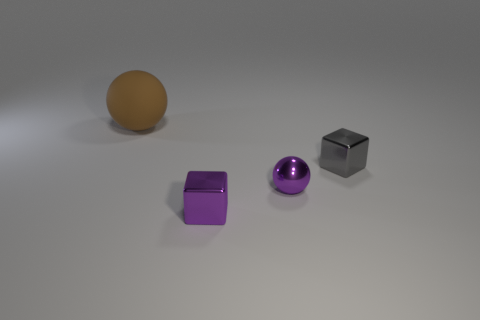What shape is the thing that is the same color as the metallic ball?
Give a very brief answer. Cube. Is there a object that has the same color as the metal sphere?
Offer a terse response. Yes. What is the material of the ball in front of the big brown rubber sphere?
Offer a terse response. Metal. Does the rubber object have the same shape as the gray object?
Keep it short and to the point. No. There is a ball right of the big brown rubber ball; what color is it?
Offer a very short reply. Purple. Is the brown rubber ball the same size as the gray shiny cube?
Give a very brief answer. No. There is a object right of the sphere on the right side of the brown matte thing; what is it made of?
Make the answer very short. Metal. What number of metal blocks are the same color as the tiny sphere?
Your answer should be compact. 1. Is there anything else that has the same material as the purple sphere?
Your answer should be compact. Yes. Are there fewer small shiny cubes in front of the large brown matte object than gray cubes?
Offer a terse response. No. 